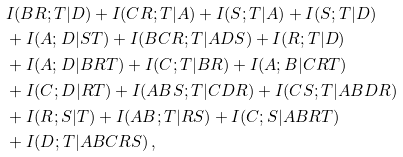Convert formula to latex. <formula><loc_0><loc_0><loc_500><loc_500>& \ \ I ( B R ; T | D ) + I ( C R ; T | A ) + I ( S ; T | A ) + I ( S ; T | D ) \\ & \ \ + I ( A ; D | S T ) + I ( B C R ; T | A D S ) + I ( R ; T | D ) \\ & \ \ + I ( A ; D | B R T ) + I ( C ; T | B R ) + I ( A ; B | C R T ) \\ & \ \ + I ( C ; D | R T ) + I ( A B S ; T | C D R ) + I ( C S ; T | A B D R ) \\ & \ \ + I ( R ; S | T ) + I ( A B ; T | R S ) + I ( C ; S | A B R T ) \\ & \ \ + I ( D ; T | A B C R S ) \, ,</formula> 